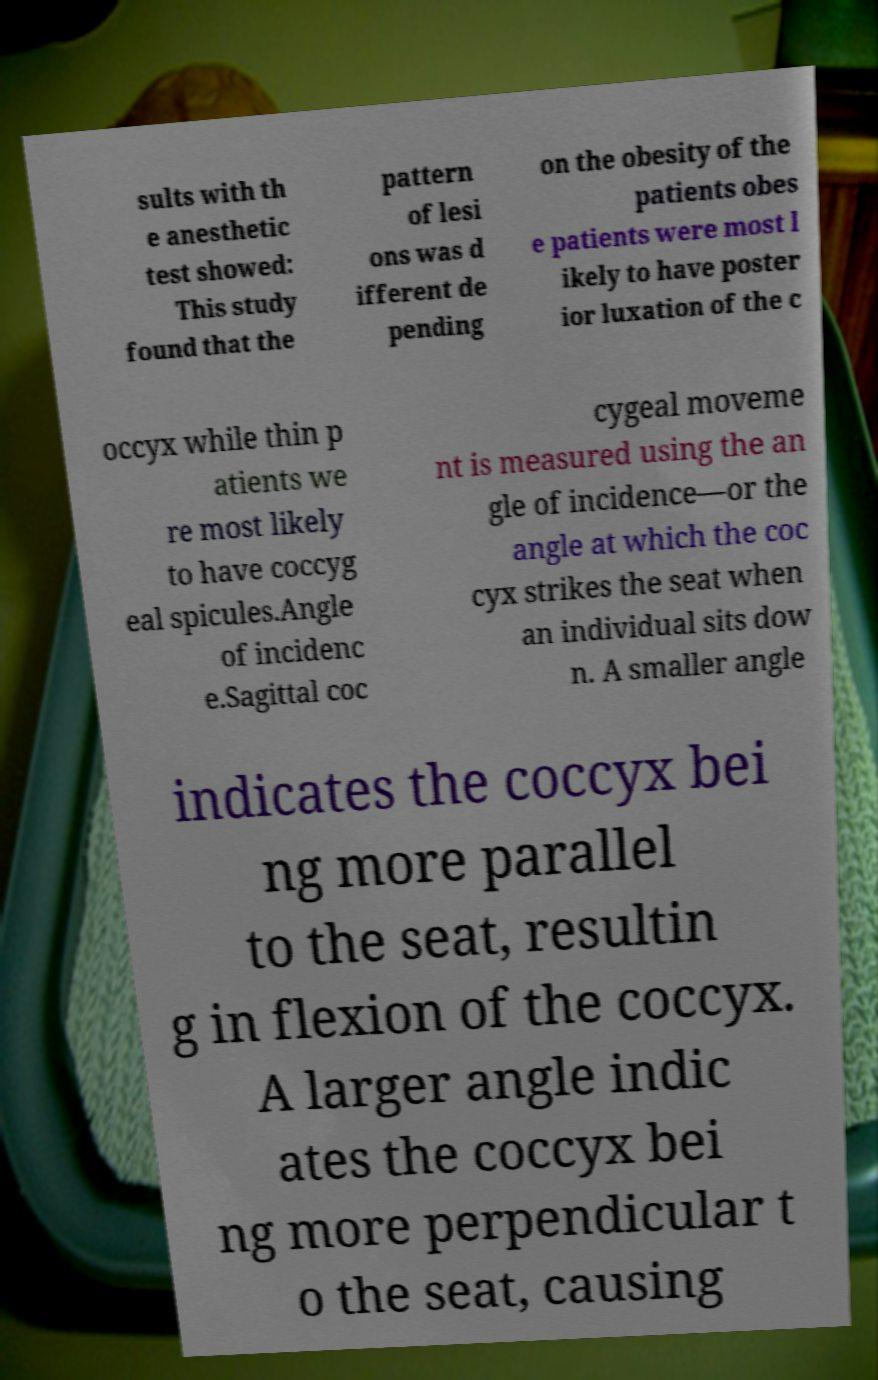I need the written content from this picture converted into text. Can you do that? sults with th e anesthetic test showed: This study found that the pattern of lesi ons was d ifferent de pending on the obesity of the patients obes e patients were most l ikely to have poster ior luxation of the c occyx while thin p atients we re most likely to have coccyg eal spicules.Angle of incidenc e.Sagittal coc cygeal moveme nt is measured using the an gle of incidence—or the angle at which the coc cyx strikes the seat when an individual sits dow n. A smaller angle indicates the coccyx bei ng more parallel to the seat, resultin g in flexion of the coccyx. A larger angle indic ates the coccyx bei ng more perpendicular t o the seat, causing 